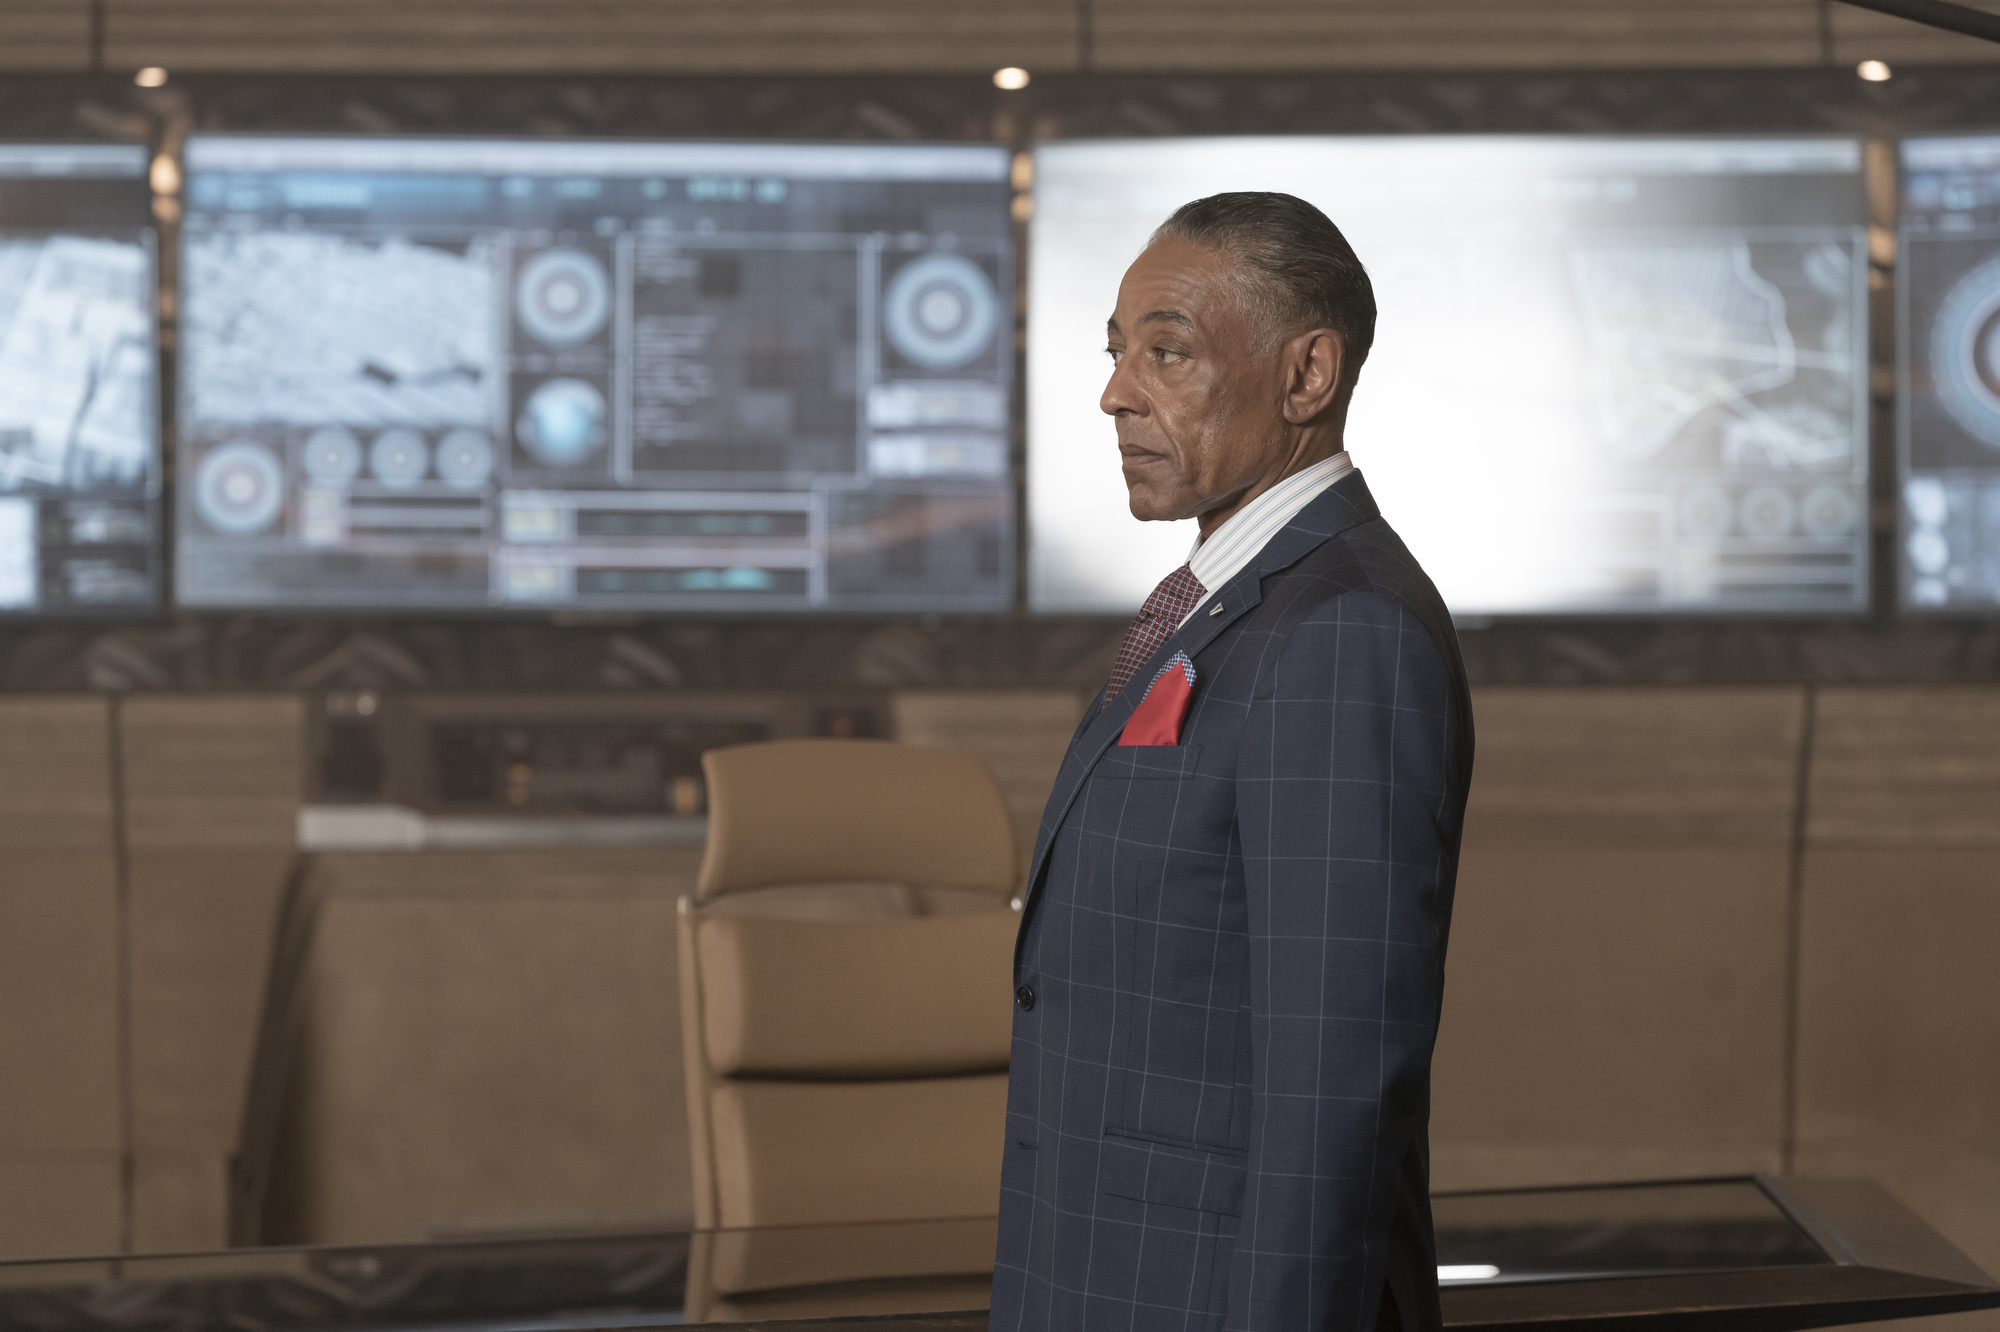Write a detailed description of the given image. The image depicts a middle-aged man in a sophisticated blue checkered suit with a prominent red pocket square, standing in a modern control room. His expression is serious and contemplative. Behind him, multiple screens display various types of data and maps, indicating a setting that involves surveillance or monitoring. The room is elegantly designed with a minimalistic approach, featuring gray tones and a subtle integration of wood paneling, enhancing the high-tech, sleek ambiance. 